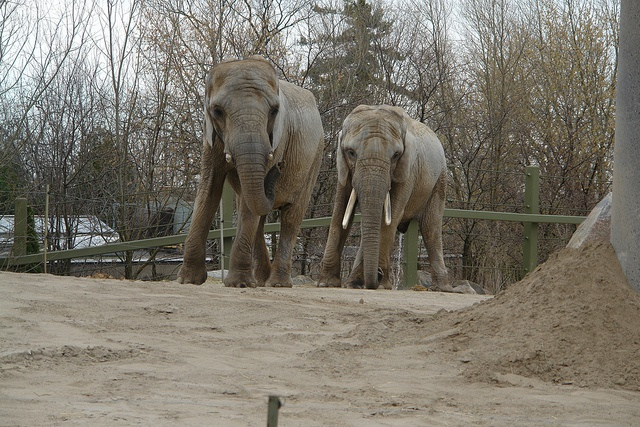Describe the objects in this image and their specific colors. I can see elephant in darkgray, gray, and black tones and elephant in darkgray, gray, and black tones in this image. 